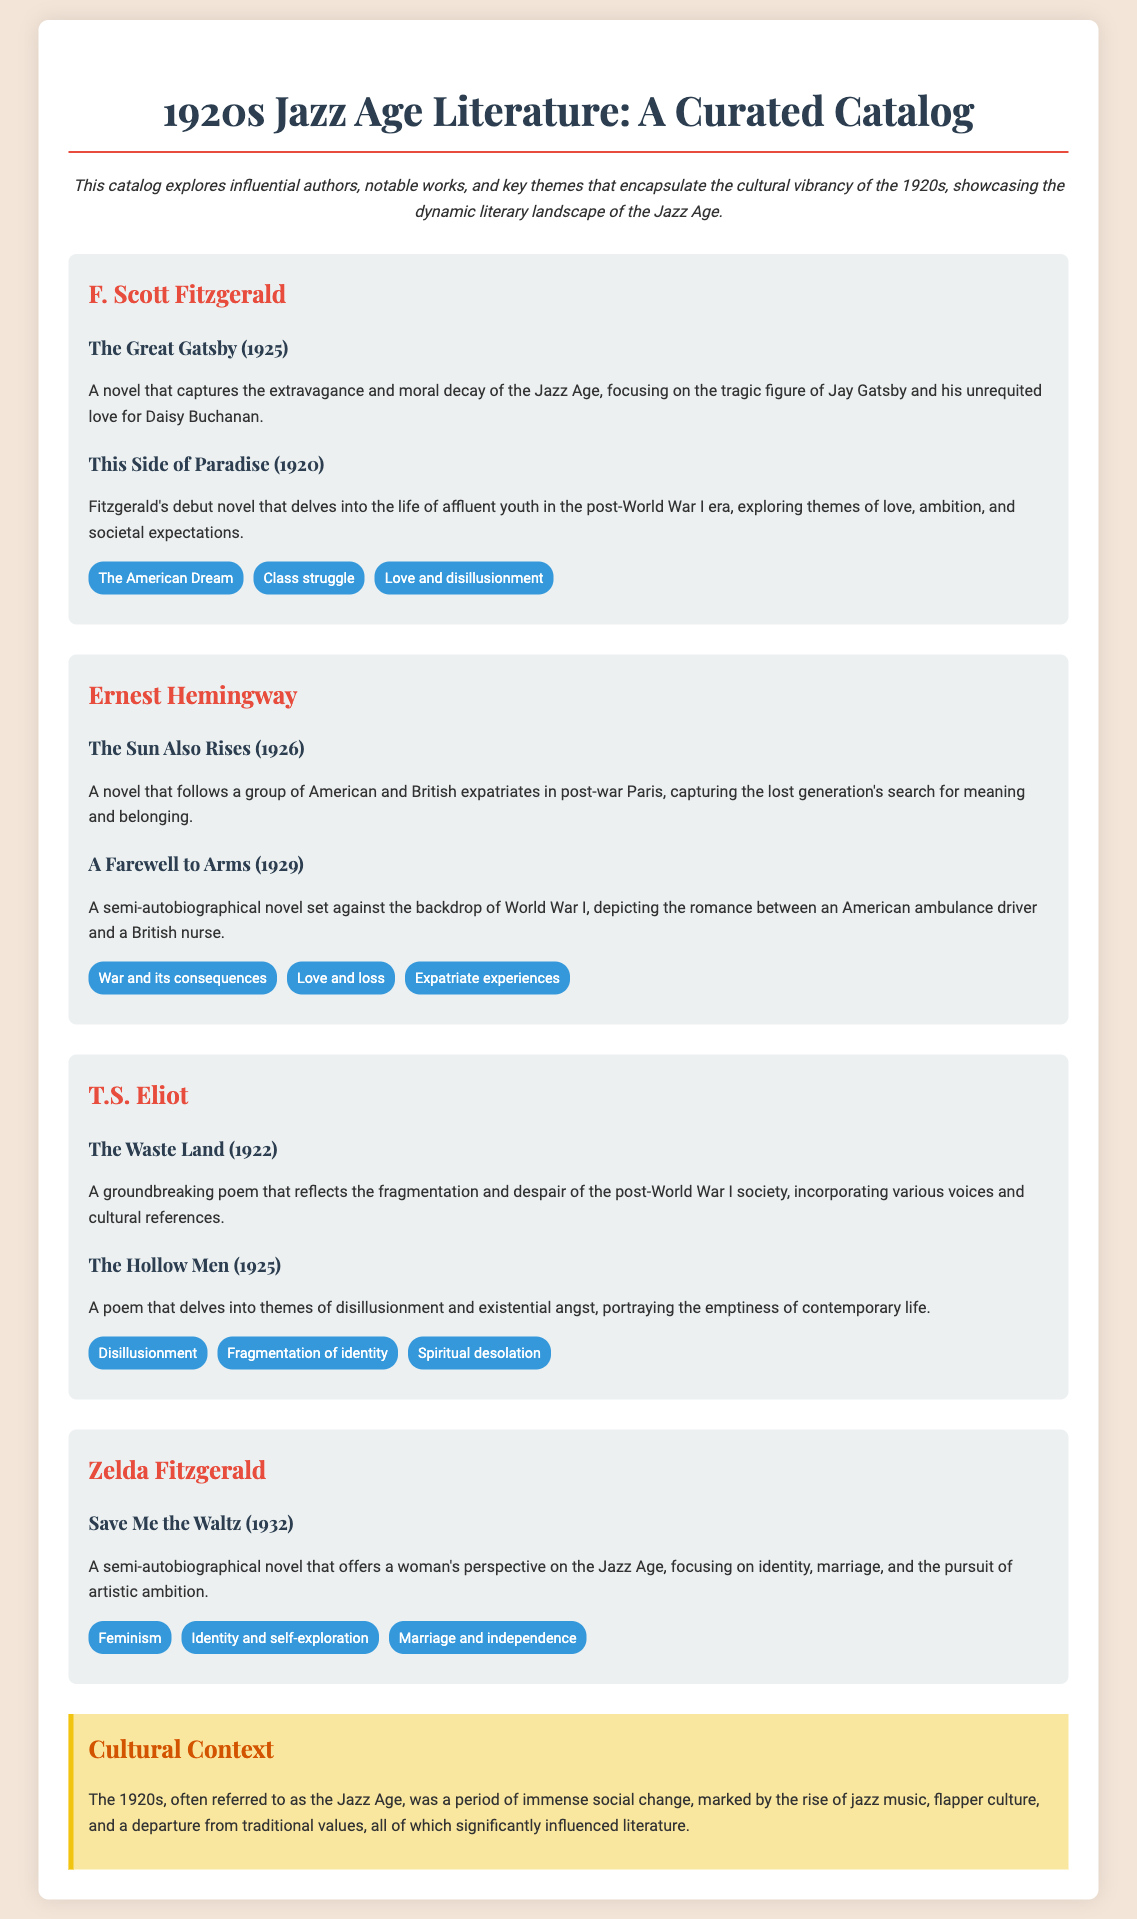what is the title of F. Scott Fitzgerald's novel published in 1925? The title is mentioned under F. Scott Fitzgerald's works section, which is "The Great Gatsby."
Answer: The Great Gatsby who authored "The Waste Land"? The author of "The Waste Land" is listed under T.S. Eliot's section.
Answer: T.S. Eliot what major cultural movement is referred to in the document? The document describes the 1920s as the "Jazz Age," which is a major cultural movement of the time.
Answer: Jazz Age in what year was "A Farewell to Arms" published? The publication year for "A Farewell to Arms" is provided in Ernest Hemingway's works section, which is 1929.
Answer: 1929 which theme is associated with Zelda Fitzgerald's writing? The themes related to Zelda Fitzgerald's work are listed, and one of them is "Feminism."
Answer: Feminism what literary form does T.S. Eliot's "The Waste Land" represent? The document indicates that "The Waste Land" is a groundbreaking poem, which reflects its literary form.
Answer: Poem what is a key theme in F. Scott Fitzgerald's works? A key theme from F. Scott Fitzgerald's selected themes is "The American Dream."
Answer: The American Dream what does the cultural context section highlight about the 1920s? The cultural context section discusses social changes, particularly the rise of jazz music and flapper culture during the 1920s.
Answer: Social change 